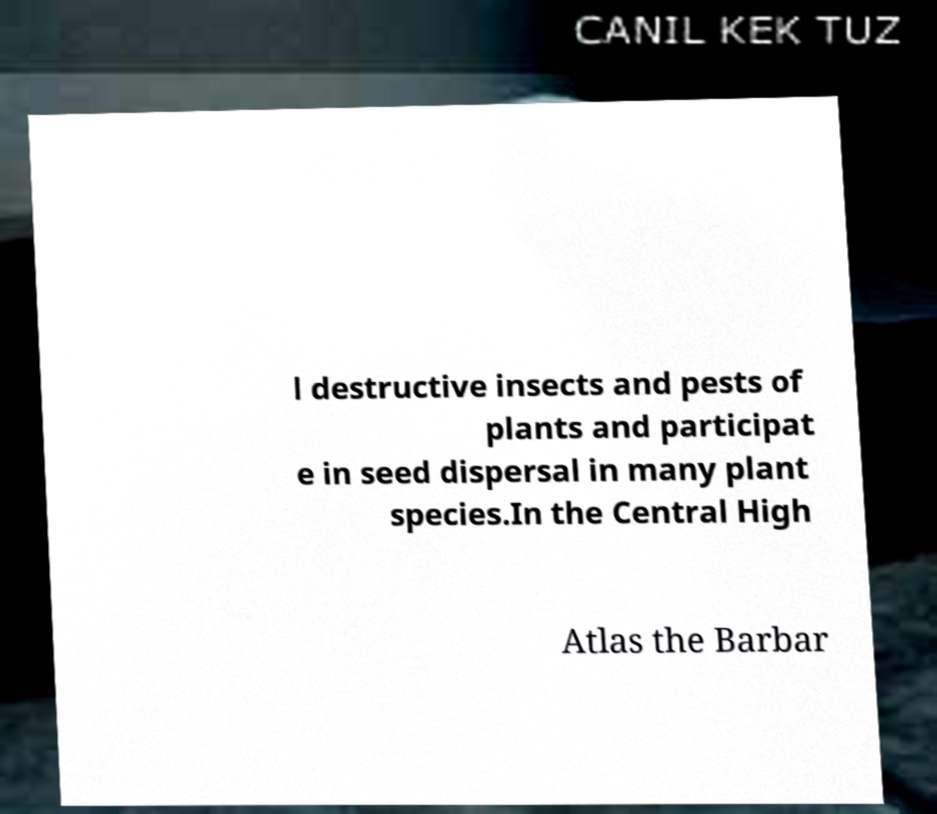Can you accurately transcribe the text from the provided image for me? l destructive insects and pests of plants and participat e in seed dispersal in many plant species.In the Central High Atlas the Barbar 